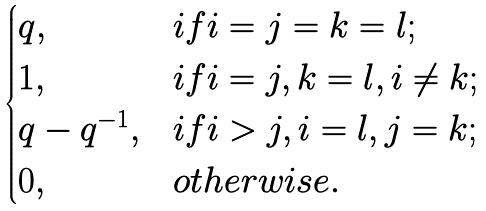<formula> <loc_0><loc_0><loc_500><loc_500>\begin{cases} q , & i f i = j = k = l ; \\ 1 , & i f i = j , k = l , i \neq k ; \\ q - q ^ { - 1 } , & i f i > j , i = l , j = k ; \\ 0 , & o t h e r w i s e . \end{cases}</formula> 